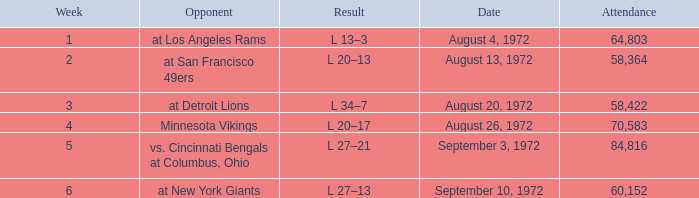How many weeks had an attendance larger than 84,816? 0.0. 